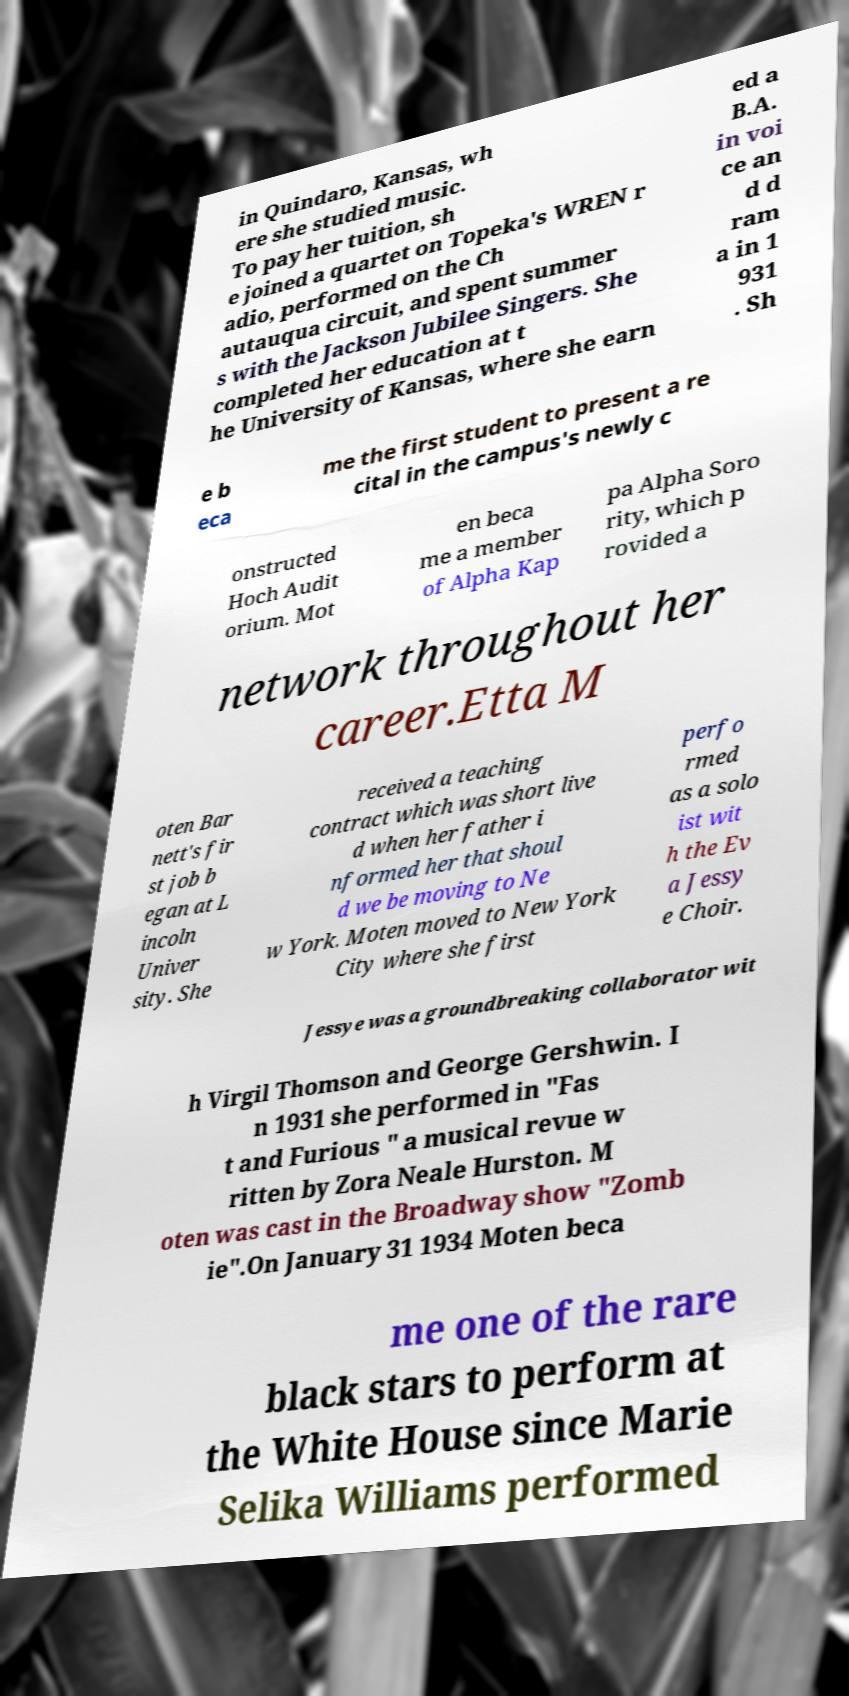Please read and relay the text visible in this image. What does it say? in Quindaro, Kansas, wh ere she studied music. To pay her tuition, sh e joined a quartet on Topeka's WREN r adio, performed on the Ch autauqua circuit, and spent summer s with the Jackson Jubilee Singers. She completed her education at t he University of Kansas, where she earn ed a B.A. in voi ce an d d ram a in 1 931 . Sh e b eca me the first student to present a re cital in the campus's newly c onstructed Hoch Audit orium. Mot en beca me a member of Alpha Kap pa Alpha Soro rity, which p rovided a network throughout her career.Etta M oten Bar nett's fir st job b egan at L incoln Univer sity. She received a teaching contract which was short live d when her father i nformed her that shoul d we be moving to Ne w York. Moten moved to New York City where she first perfo rmed as a solo ist wit h the Ev a Jessy e Choir. Jessye was a groundbreaking collaborator wit h Virgil Thomson and George Gershwin. I n 1931 she performed in "Fas t and Furious " a musical revue w ritten by Zora Neale Hurston. M oten was cast in the Broadway show "Zomb ie".On January 31 1934 Moten beca me one of the rare black stars to perform at the White House since Marie Selika Williams performed 